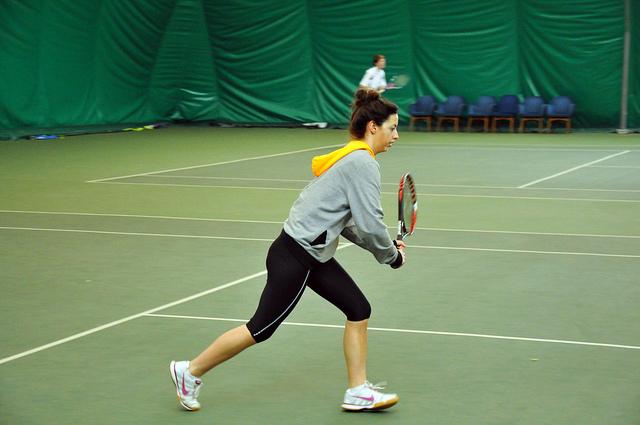Is she a professional tennis player?
Concise answer only. No. Is there a logo on a tennis racket?
Concise answer only. No. What is the tennis player wearing on her head?
Be succinct. Nothing. What is the woman holding?
Keep it brief. Tennis racket. What kind of surface are they playing on?
Keep it brief. Tennis court. Is the woman in motion?
Give a very brief answer. Yes. How is the player dressed?
Concise answer only. Casual. What brand of shoes is the woman wearing?
Give a very brief answer. Nike. 